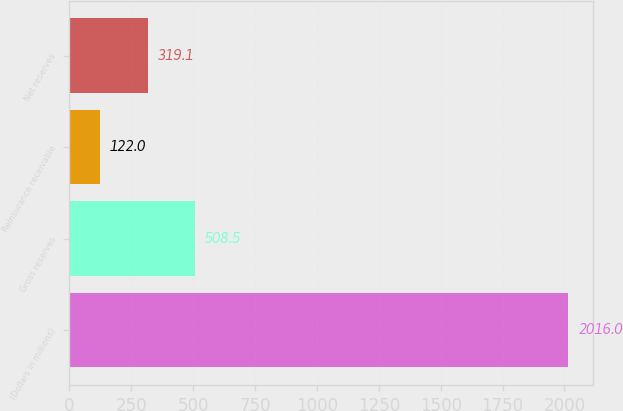Convert chart to OTSL. <chart><loc_0><loc_0><loc_500><loc_500><bar_chart><fcel>(Dollars in millions)<fcel>Gross reserves<fcel>Reinsurance receivable<fcel>Net reserves<nl><fcel>2016<fcel>508.5<fcel>122<fcel>319.1<nl></chart> 